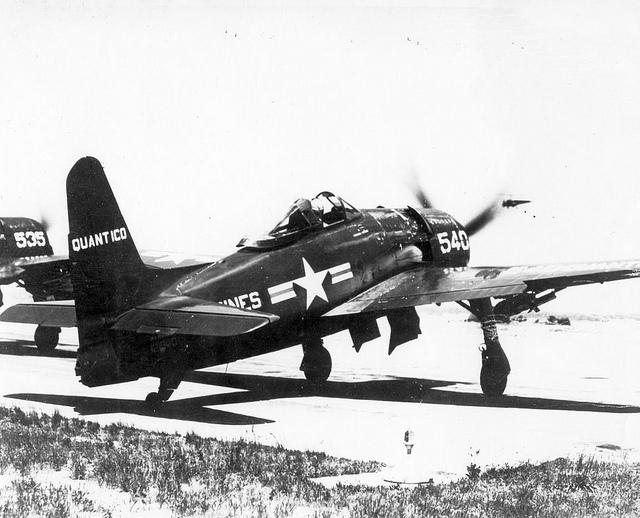Is this a modern plane?
Concise answer only. No. What's the number on the closest plane?
Quick response, please. 540. Is here an army base?
Be succinct. Yes. 